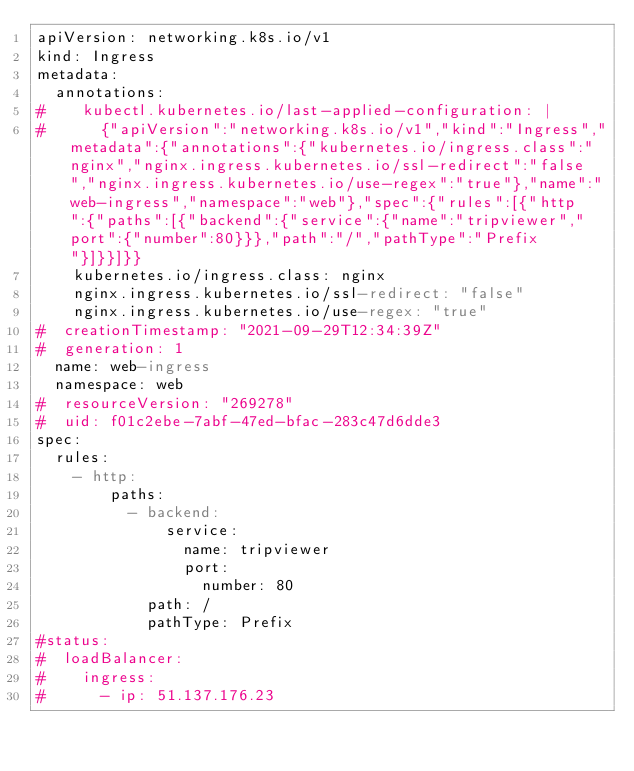Convert code to text. <code><loc_0><loc_0><loc_500><loc_500><_YAML_>apiVersion: networking.k8s.io/v1
kind: Ingress
metadata:
  annotations:
#    kubectl.kubernetes.io/last-applied-configuration: |
#      {"apiVersion":"networking.k8s.io/v1","kind":"Ingress","metadata":{"annotations":{"kubernetes.io/ingress.class":"nginx","nginx.ingress.kubernetes.io/ssl-redirect":"false","nginx.ingress.kubernetes.io/use-regex":"true"},"name":"web-ingress","namespace":"web"},"spec":{"rules":[{"http":{"paths":[{"backend":{"service":{"name":"tripviewer","port":{"number":80}}},"path":"/","pathType":"Prefix"}]}}]}}
    kubernetes.io/ingress.class: nginx
    nginx.ingress.kubernetes.io/ssl-redirect: "false"
    nginx.ingress.kubernetes.io/use-regex: "true"
#  creationTimestamp: "2021-09-29T12:34:39Z"
#  generation: 1
  name: web-ingress
  namespace: web
#  resourceVersion: "269278"
#  uid: f01c2ebe-7abf-47ed-bfac-283c47d6dde3
spec:
  rules:
    - http:
        paths:
          - backend:
              service:
                name: tripviewer
                port:
                  number: 80
            path: /
            pathType: Prefix
#status:
#  loadBalancer:
#    ingress:
#      - ip: 51.137.176.23
</code> 